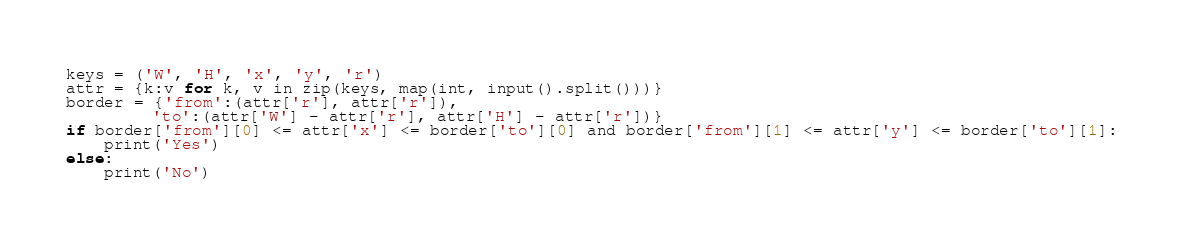<code> <loc_0><loc_0><loc_500><loc_500><_Python_>keys = ('W', 'H', 'x', 'y', 'r')
attr = {k:v for k, v in zip(keys, map(int, input().split()))}
border = {'from':(attr['r'], attr['r']),
         'to':(attr['W'] - attr['r'], attr['H'] - attr['r'])}
if border['from'][0] <= attr['x'] <= border['to'][0] and border['from'][1] <= attr['y'] <= border['to'][1]:
    print('Yes')
else:
    print('No')</code> 